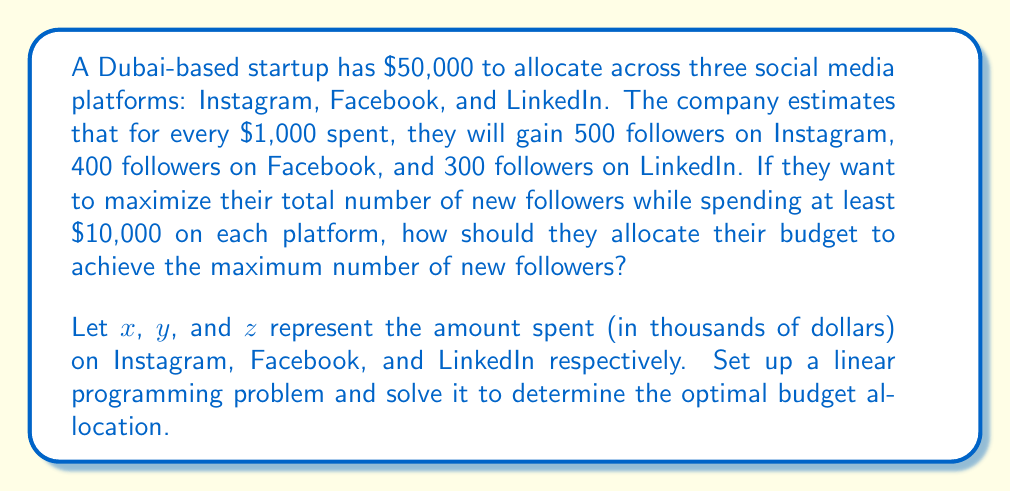Can you solve this math problem? Let's approach this step-by-step:

1) First, we need to set up our objective function. We want to maximize the total number of followers:

   Maximize: $500x + 400y + 300z$

2) Now, let's define our constraints:
   
   Total budget: $x + y + z = 50$ (since the total budget is $50,000)
   Minimum spend on each platform: $x \geq 10$, $y \geq 10$, $z \geq 10$

3) Our linear programming problem is now:

   Maximize: $500x + 400y + 300z$
   Subject to:
   $x + y + z = 50$
   $x \geq 10$
   $y \geq 10$
   $z \geq 10$

4) To solve this, we can use the corner point method. The feasible region is a triangle on the plane $x + y + z = 50$.

5) The corner points are:
   (10, 10, 30), (10, 30, 10), and (30, 10, 10)

6) Let's evaluate our objective function at each point:

   At (10, 10, 30): $500(10) + 400(10) + 300(30) = 18,000$
   At (10, 30, 10): $500(10) + 400(30) + 300(10) = 20,000$
   At (30, 10, 10): $500(30) + 400(10) + 300(10) = 22,000$

7) The maximum value is achieved at the point (30, 10, 10), which corresponds to spending $30,000 on Instagram, $10,000 on Facebook, and $10,000 on LinkedIn.
Answer: $30,000 on Instagram, $10,000 on Facebook, $10,000 on LinkedIn 